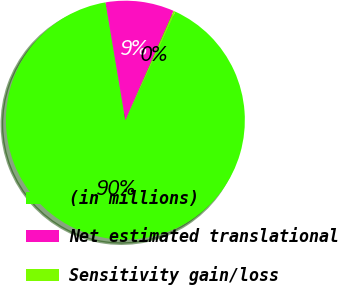Convert chart. <chart><loc_0><loc_0><loc_500><loc_500><pie_chart><fcel>(in millions)<fcel>Net estimated translational<fcel>Sensitivity gain/loss<nl><fcel>90.49%<fcel>9.27%<fcel>0.24%<nl></chart> 